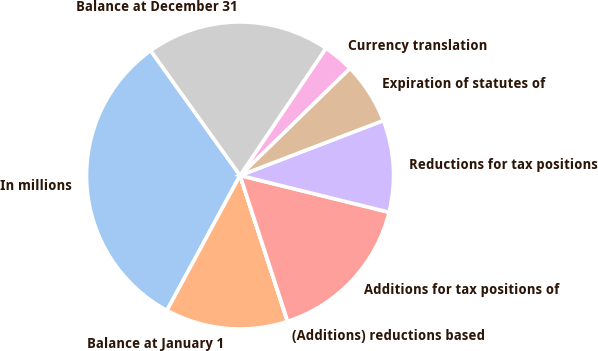<chart> <loc_0><loc_0><loc_500><loc_500><pie_chart><fcel>In millions<fcel>Balance at January 1<fcel>(Additions) reductions based<fcel>Additions for tax positions of<fcel>Reductions for tax positions<fcel>Expiration of statutes of<fcel>Currency translation<fcel>Balance at December 31<nl><fcel>32.21%<fcel>12.9%<fcel>0.03%<fcel>16.12%<fcel>9.68%<fcel>6.47%<fcel>3.25%<fcel>19.34%<nl></chart> 